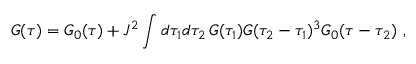<formula> <loc_0><loc_0><loc_500><loc_500>G ( \tau ) = G _ { 0 } ( \tau ) + J ^ { 2 } \int d \tau _ { 1 } d \tau _ { 2 } \, G ( \tau _ { 1 } ) G ( \tau _ { 2 } - \tau _ { 1 } ) ^ { 3 } G _ { 0 } ( \tau - \tau _ { 2 } ) ,</formula> 